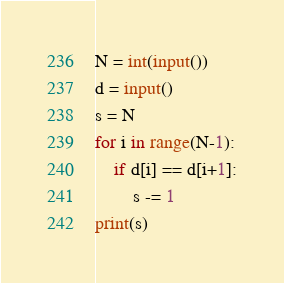<code> <loc_0><loc_0><loc_500><loc_500><_Python_>N = int(input())
d = input()
s = N
for i in range(N-1):
    if d[i] == d[i+1]:
        s -= 1
print(s)</code> 